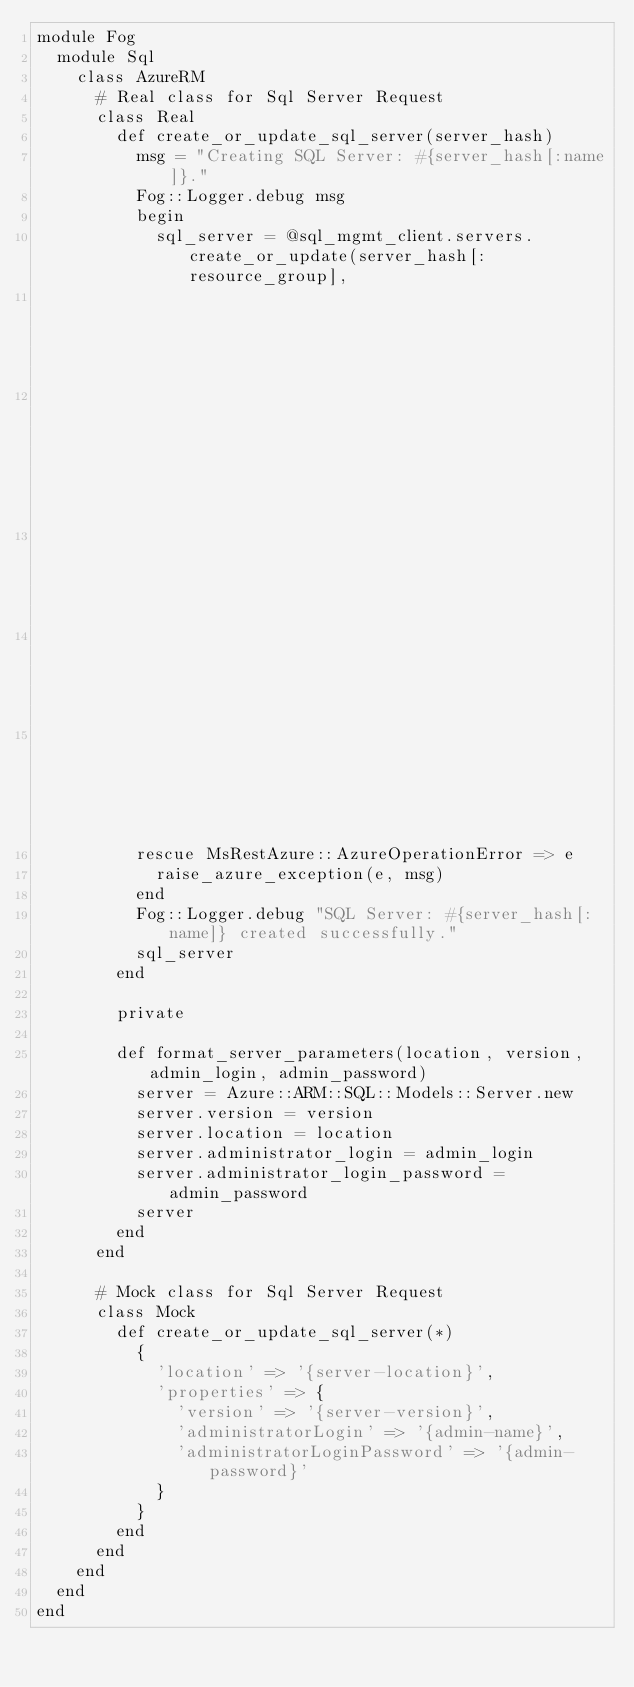Convert code to text. <code><loc_0><loc_0><loc_500><loc_500><_Ruby_>module Fog
  module Sql
    class AzureRM
      # Real class for Sql Server Request
      class Real
        def create_or_update_sql_server(server_hash)
          msg = "Creating SQL Server: #{server_hash[:name]}."
          Fog::Logger.debug msg
          begin
            sql_server = @sql_mgmt_client.servers.create_or_update(server_hash[:resource_group],
                                                                   server_hash[:name],
                                                                   format_server_parameters(server_hash[:location],
                                                                                            server_hash[:version],
                                                                                            server_hash[:administrator_login],
                                                                                            server_hash[:administrator_login_password]))
          rescue MsRestAzure::AzureOperationError => e
            raise_azure_exception(e, msg)
          end
          Fog::Logger.debug "SQL Server: #{server_hash[:name]} created successfully."
          sql_server
        end

        private

        def format_server_parameters(location, version, admin_login, admin_password)
          server = Azure::ARM::SQL::Models::Server.new
          server.version = version
          server.location = location
          server.administrator_login = admin_login
          server.administrator_login_password = admin_password
          server
        end
      end

      # Mock class for Sql Server Request
      class Mock
        def create_or_update_sql_server(*)
          {
            'location' => '{server-location}',
            'properties' => {
              'version' => '{server-version}',
              'administratorLogin' => '{admin-name}',
              'administratorLoginPassword' => '{admin-password}'
            }
          }
        end
      end
    end
  end
end
</code> 